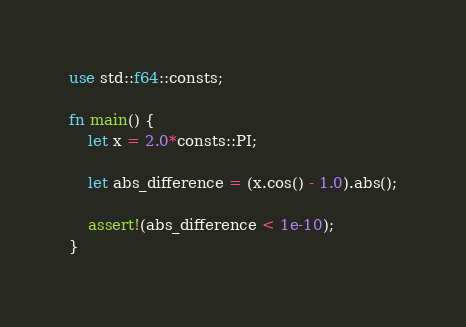<code> <loc_0><loc_0><loc_500><loc_500><_Rust_>use std::f64::consts;

fn main() {
    let x = 2.0*consts::PI;

    let abs_difference = (x.cos() - 1.0).abs();

    assert!(abs_difference < 1e-10);
}
</code> 